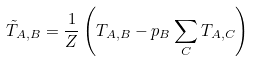<formula> <loc_0><loc_0><loc_500><loc_500>\tilde { T } _ { A , B } = \frac { 1 } { Z } \left ( T _ { A , B } - p _ { B } \sum _ { C } T _ { A , C } \right )</formula> 